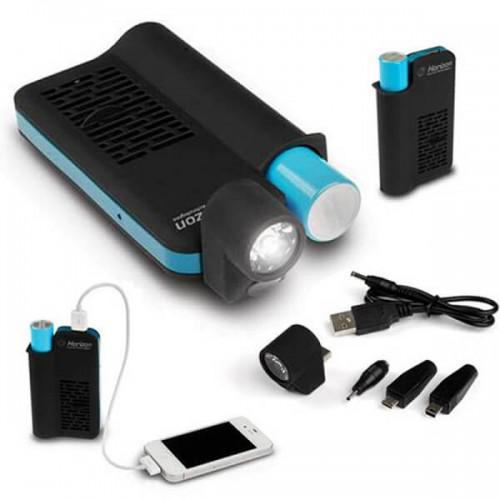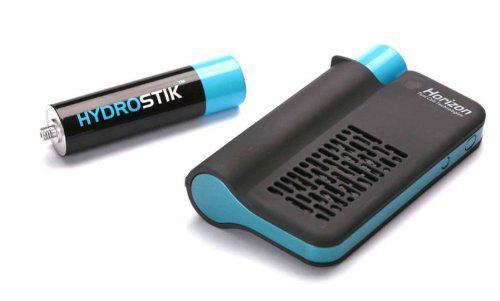The first image is the image on the left, the second image is the image on the right. Given the left and right images, does the statement "There are three devices." hold true? Answer yes or no. No. The first image is the image on the left, the second image is the image on the right. Given the left and right images, does the statement "The right image shows a flat rectangular device with a cord in it, next to a charging device with the other end of the cord in it." hold true? Answer yes or no. No. 